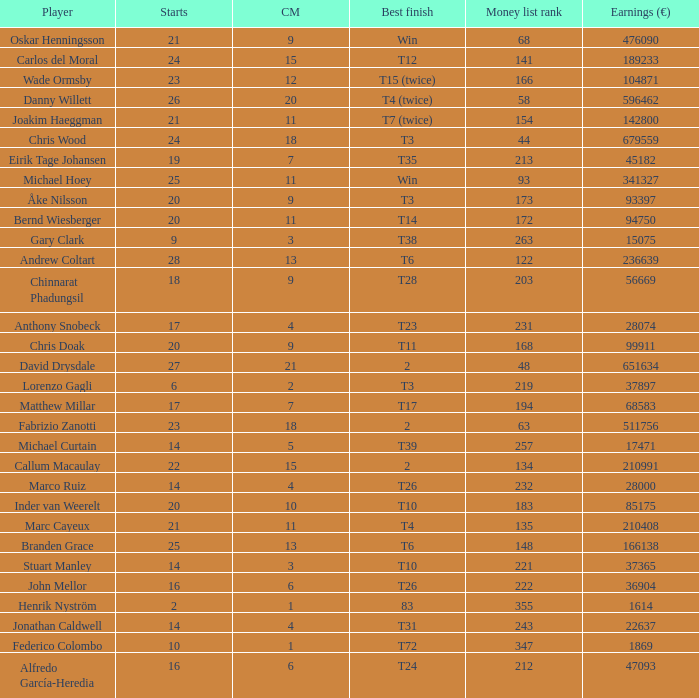How many cuts did Bernd Wiesberger make? 11.0. Would you be able to parse every entry in this table? {'header': ['Player', 'Starts', 'CM', 'Best finish', 'Money list rank', 'Earnings (€)'], 'rows': [['Oskar Henningsson', '21', '9', 'Win', '68', '476090'], ['Carlos del Moral', '24', '15', 'T12', '141', '189233'], ['Wade Ormsby', '23', '12', 'T15 (twice)', '166', '104871'], ['Danny Willett', '26', '20', 'T4 (twice)', '58', '596462'], ['Joakim Haeggman', '21', '11', 'T7 (twice)', '154', '142800'], ['Chris Wood', '24', '18', 'T3', '44', '679559'], ['Eirik Tage Johansen', '19', '7', 'T35', '213', '45182'], ['Michael Hoey', '25', '11', 'Win', '93', '341327'], ['Åke Nilsson', '20', '9', 'T3', '173', '93397'], ['Bernd Wiesberger', '20', '11', 'T14', '172', '94750'], ['Gary Clark', '9', '3', 'T38', '263', '15075'], ['Andrew Coltart', '28', '13', 'T6', '122', '236639'], ['Chinnarat Phadungsil', '18', '9', 'T28', '203', '56669'], ['Anthony Snobeck', '17', '4', 'T23', '231', '28074'], ['Chris Doak', '20', '9', 'T11', '168', '99911'], ['David Drysdale', '27', '21', '2', '48', '651634'], ['Lorenzo Gagli', '6', '2', 'T3', '219', '37897'], ['Matthew Millar', '17', '7', 'T17', '194', '68583'], ['Fabrizio Zanotti', '23', '18', '2', '63', '511756'], ['Michael Curtain', '14', '5', 'T39', '257', '17471'], ['Callum Macaulay', '22', '15', '2', '134', '210991'], ['Marco Ruiz', '14', '4', 'T26', '232', '28000'], ['Inder van Weerelt', '20', '10', 'T10', '183', '85175'], ['Marc Cayeux', '21', '11', 'T4', '135', '210408'], ['Branden Grace', '25', '13', 'T6', '148', '166138'], ['Stuart Manley', '14', '3', 'T10', '221', '37365'], ['John Mellor', '16', '6', 'T26', '222', '36904'], ['Henrik Nyström', '2', '1', '83', '355', '1614'], ['Jonathan Caldwell', '14', '4', 'T31', '243', '22637'], ['Federico Colombo', '10', '1', 'T72', '347', '1869'], ['Alfredo García-Heredia', '16', '6', 'T24', '212', '47093']]} 